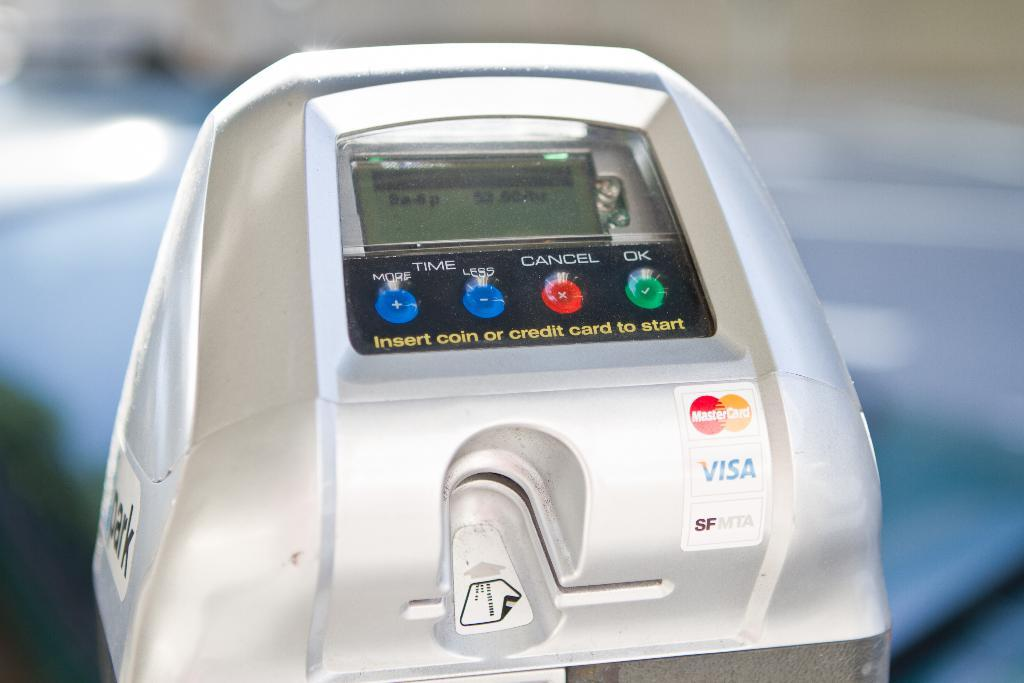What is the main object in the image? There is a machine in the image. What feature does the machine have? The machine has a screen. What can be found below the screen? There are buttons below the screen. Where is the card inserting area located on the machine? The card inserting area is at the bottom of the machine. How many women are pushing carts in the image? There are no women or carts present in the image; it features a machine with a screen, buttons, and a card inserting area. 